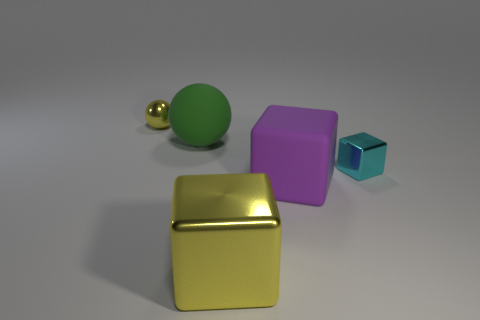How many things are green balls or small brown matte cylinders?
Ensure brevity in your answer.  1. Is the small cyan metal object the same shape as the large metallic object?
Offer a terse response. Yes. What material is the tiny ball?
Keep it short and to the point. Metal. How many tiny things are both on the right side of the tiny yellow sphere and behind the big green object?
Provide a succinct answer. 0. Do the purple block and the yellow sphere have the same size?
Provide a short and direct response. No. There is a cyan metallic cube in front of the yellow metal ball; is it the same size as the large yellow thing?
Offer a very short reply. No. What is the color of the sphere right of the yellow sphere?
Provide a succinct answer. Green. What number of cyan things are there?
Your answer should be very brief. 1. What is the shape of the big yellow object that is the same material as the tiny cube?
Give a very brief answer. Cube. Do the big block in front of the purple matte block and the small object that is behind the green rubber object have the same color?
Keep it short and to the point. Yes. 